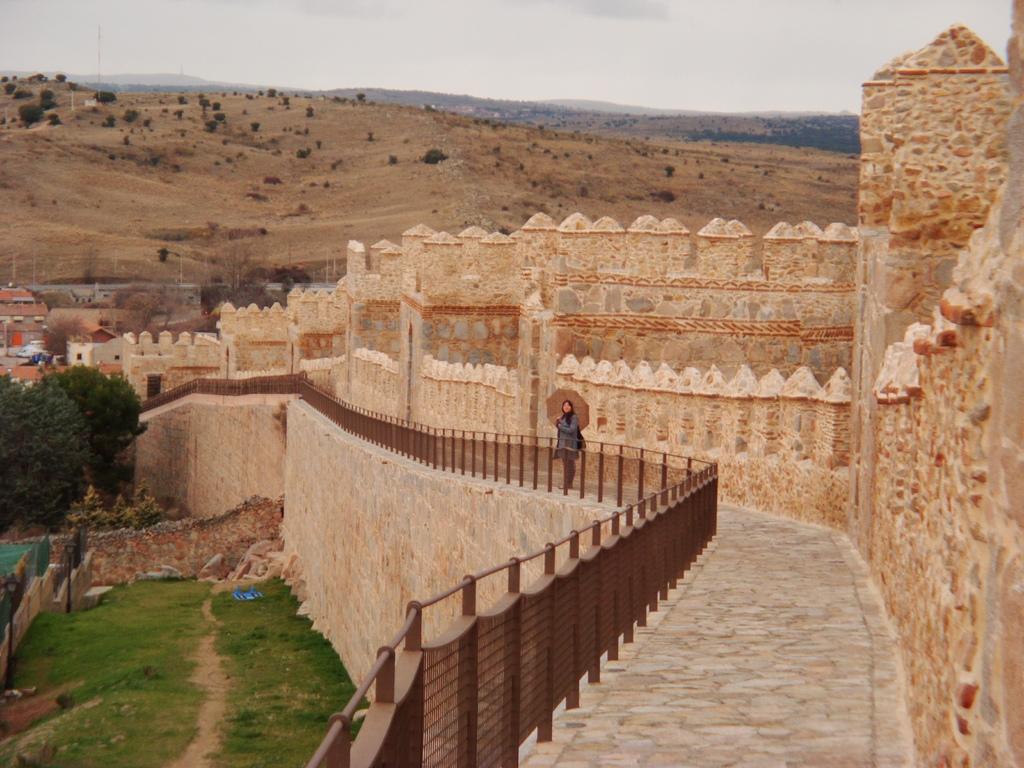In one or two sentences, can you explain what this image depicts? In the picture I can see a person is standing here, here we can see the railing, stone wall, fort, grass, trees, hills and the sky in the background. 